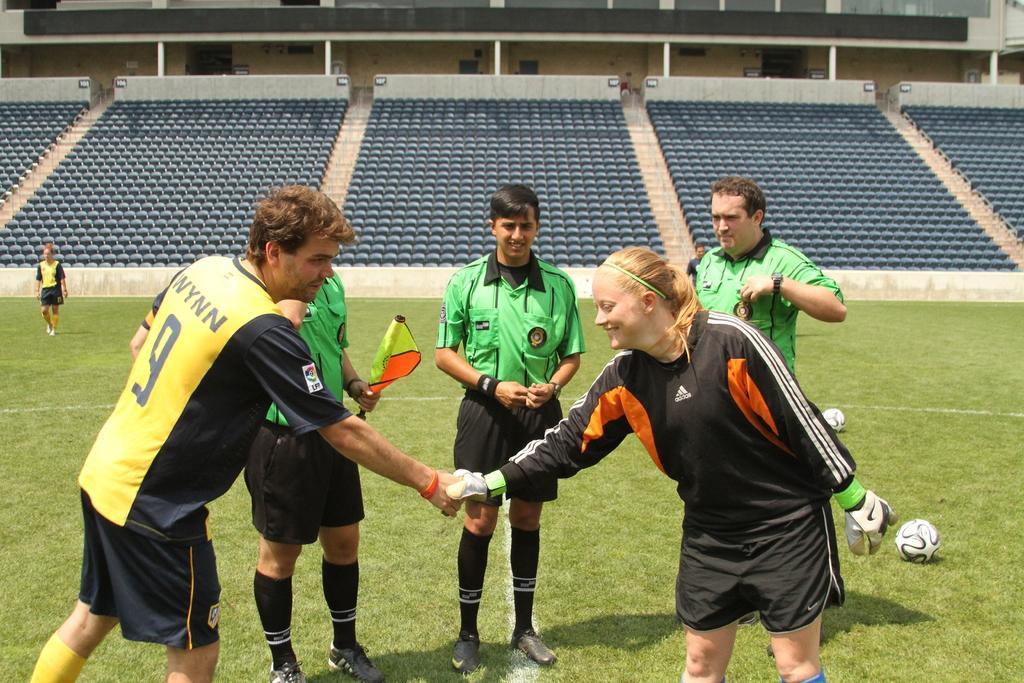How would you summarize this image in a sentence or two? In this image in the foreground there is one man and one woman who are shaking hands with each other, and in the background there are three people standing and one person is holding a flag. And at the bottom there is grass, on the grass there are two balls. On the left side there is another person, in the background there are some chairs, wall, poles and building. 